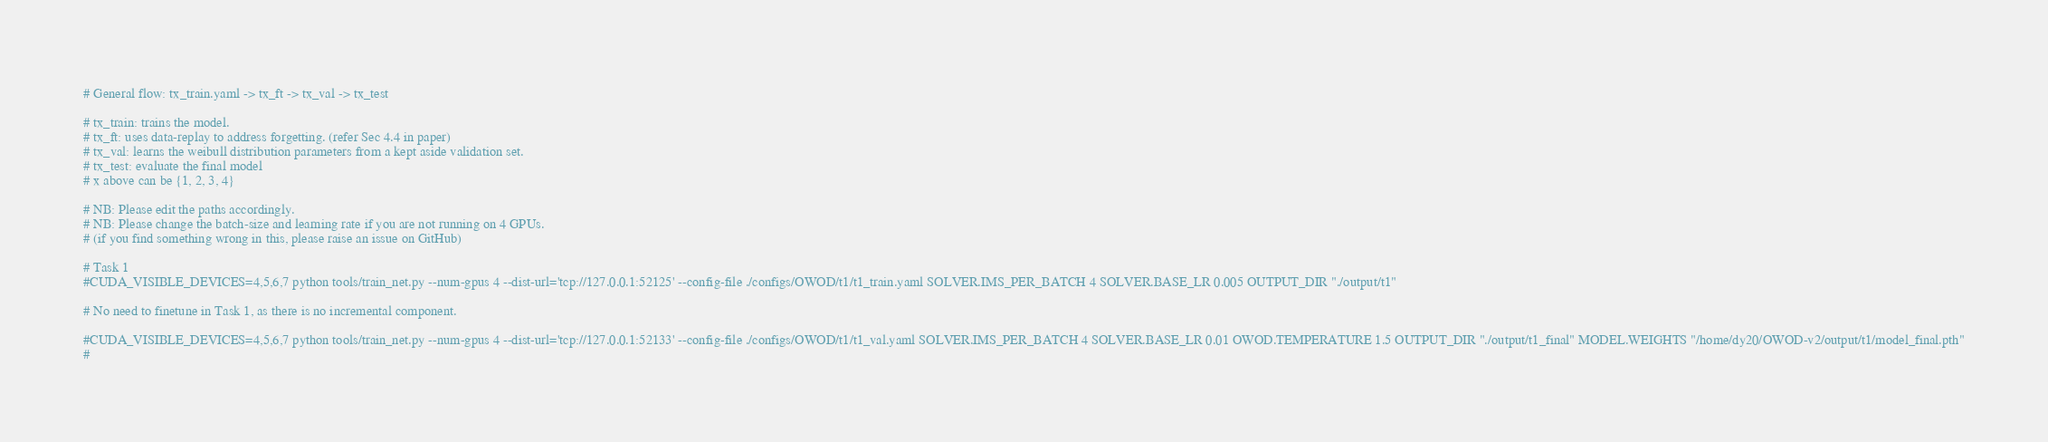<code> <loc_0><loc_0><loc_500><loc_500><_Bash_># General flow: tx_train.yaml -> tx_ft -> tx_val -> tx_test

# tx_train: trains the model.
# tx_ft: uses data-replay to address forgetting. (refer Sec 4.4 in paper)
# tx_val: learns the weibull distribution parameters from a kept aside validation set.
# tx_test: evaluate the final model
# x above can be {1, 2, 3, 4}

# NB: Please edit the paths accordingly.
# NB: Please change the batch-size and learning rate if you are not running on 4 GPUs.
# (if you find something wrong in this, please raise an issue on GitHub)

# Task 1
#CUDA_VISIBLE_DEVICES=4,5,6,7 python tools/train_net.py --num-gpus 4 --dist-url='tcp://127.0.0.1:52125' --config-file ./configs/OWOD/t1/t1_train.yaml SOLVER.IMS_PER_BATCH 4 SOLVER.BASE_LR 0.005 OUTPUT_DIR "./output/t1"

# No need to finetune in Task 1, as there is no incremental component.

#CUDA_VISIBLE_DEVICES=4,5,6,7 python tools/train_net.py --num-gpus 4 --dist-url='tcp://127.0.0.1:52133' --config-file ./configs/OWOD/t1/t1_val.yaml SOLVER.IMS_PER_BATCH 4 SOLVER.BASE_LR 0.01 OWOD.TEMPERATURE 1.5 OUTPUT_DIR "./output/t1_final" MODEL.WEIGHTS "/home/dy20/OWOD-v2/output/t1/model_final.pth"
#</code> 